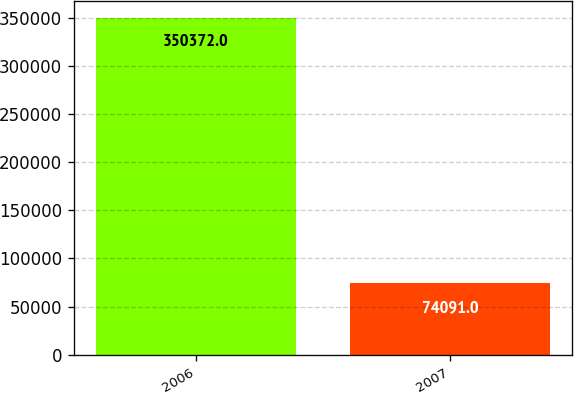Convert chart to OTSL. <chart><loc_0><loc_0><loc_500><loc_500><bar_chart><fcel>2006<fcel>2007<nl><fcel>350372<fcel>74091<nl></chart> 